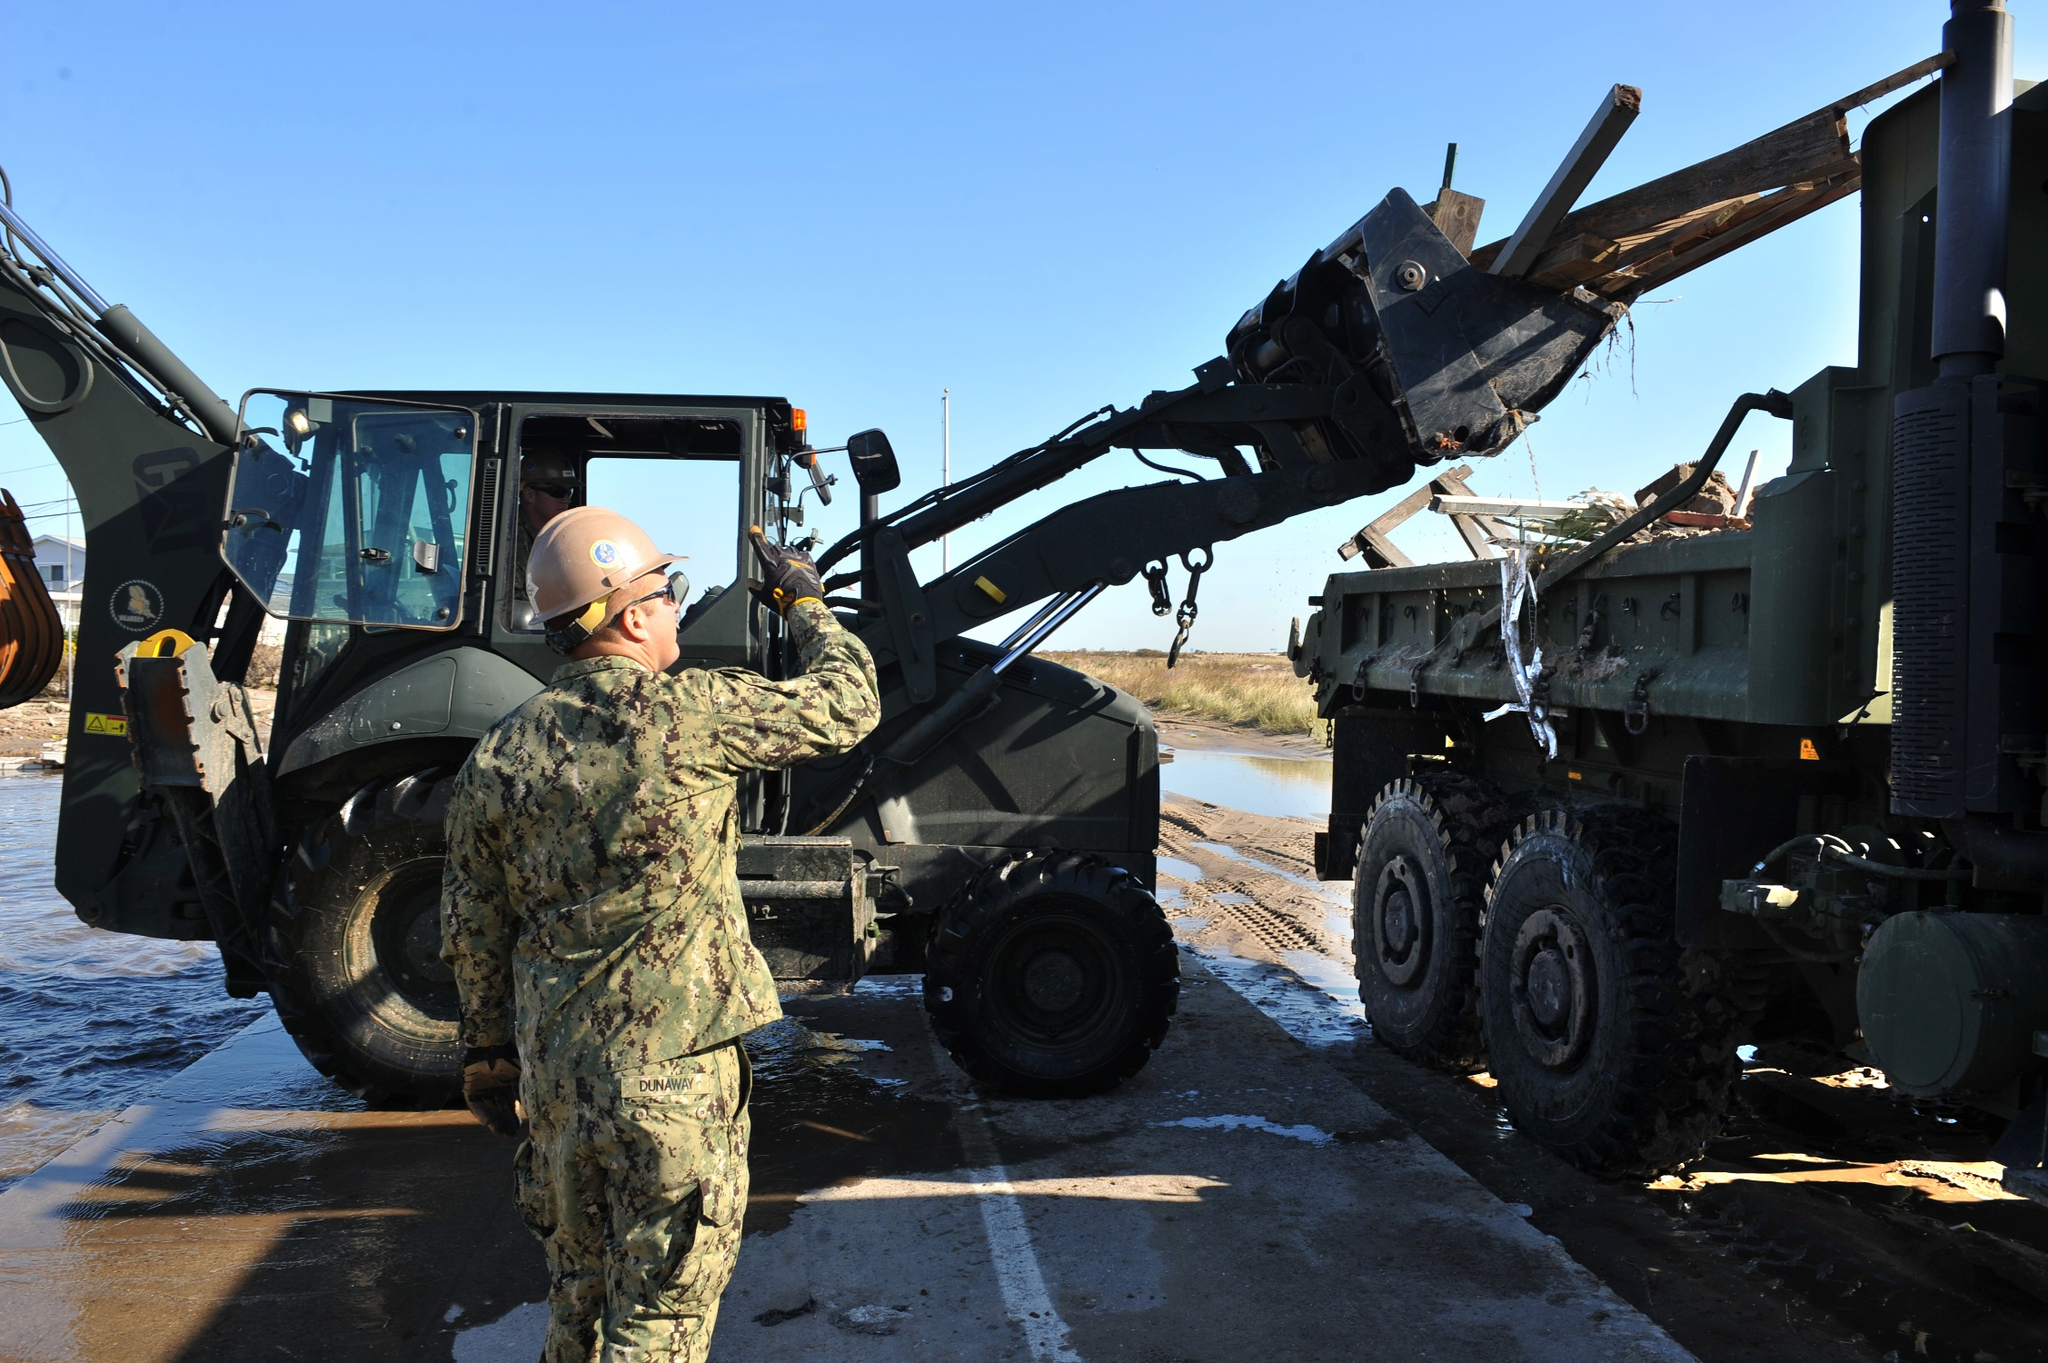What might be the purpose of moving these wooden beams from the truck at this site? The wooden beams are likely being moved to facilitate construction or repair work at this site. These beams could be intended for building structures, reinforcing existing ones, or possibly for creating temporary supports or framing. The precision with which the worker operates the forklift suggests the importance of these materials in ensuring the stability and safety of whatever project is underway. 